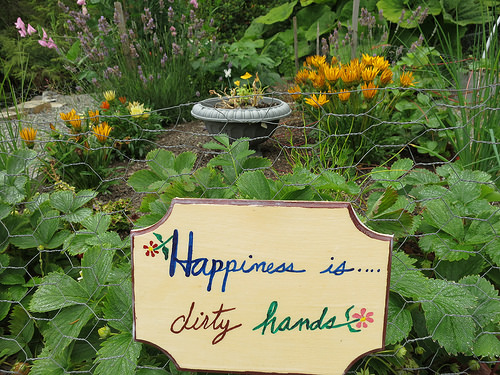<image>
Is the flower to the left of the flower pot? Yes. From this viewpoint, the flower is positioned to the left side relative to the flower pot. 